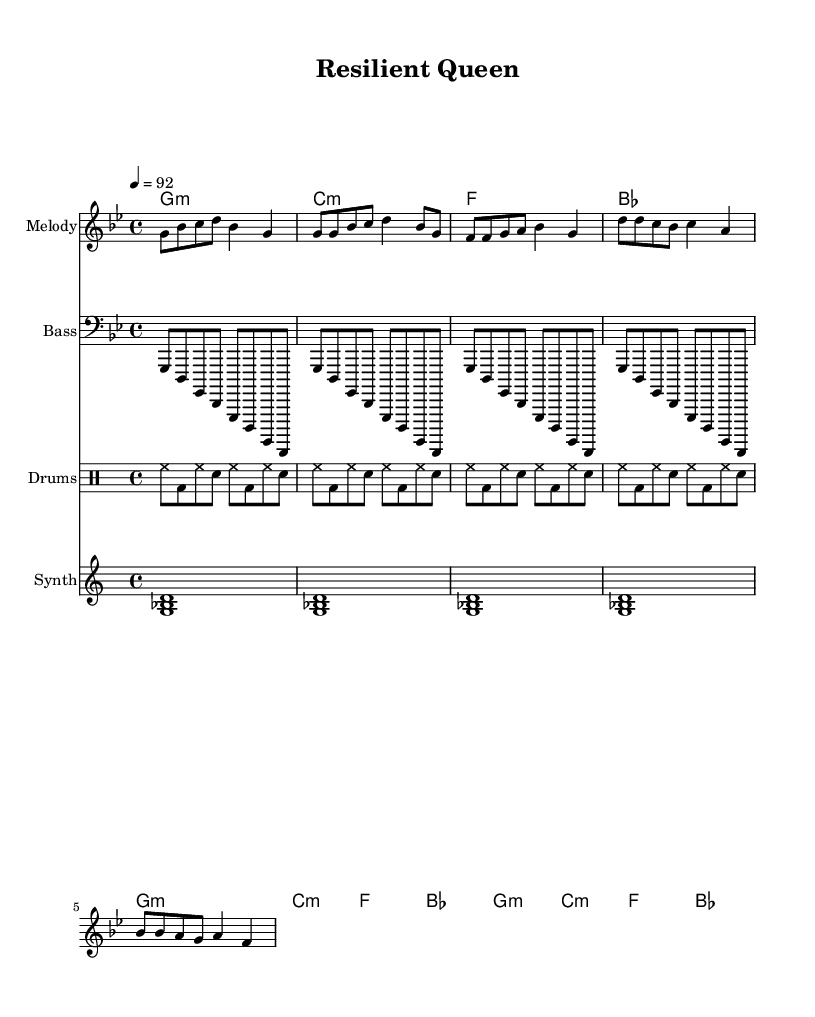What is the key signature of this music? The key signature is G minor, which has two flats (B♭ and E♭) noted at the beginning of the staff.
Answer: G minor What is the time signature of this music? The time signature is found at the beginning of the sheet music, indicated by the fraction 4/4, which represents four beats per measure.
Answer: 4/4 What is the tempo of this piece? The tempo marking, shown above the staff, indicates a speed of 92 beats per minute using the quarter note as the beat unit.
Answer: 92 How many measures are in the verse section? By counting the measures in the specified verse section, which consists of four lines, each with four measures, we find a total of 16 measures in the verse.
Answer: 16 What type of instrumentation is used in this piece? The score includes a melody staff for the main tune, a bass staff for lower notes, a drum staff for rhythms, and a synth pad staff for atmospheric sounds, all typical for hip-hop music.
Answer: Melody, Bass, Drums, Synth What rhythmic pattern is used in the drum section? The drum pattern is notated in the drummode section, which alternates between hi-hats, bass drums, and snare hits in a consistent sequence across the measures, reflecting common hip-hop drumming techniques.
Answer: Hi-hat, Bass, Snare 